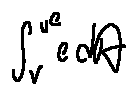<formula> <loc_0><loc_0><loc_500><loc_500>\int \lim i t s _ { v } ^ { \mu e } e d A</formula> 